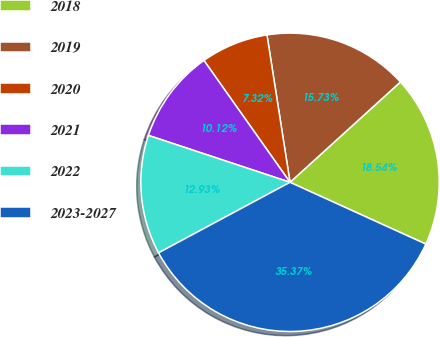Convert chart. <chart><loc_0><loc_0><loc_500><loc_500><pie_chart><fcel>2018<fcel>2019<fcel>2020<fcel>2021<fcel>2022<fcel>2023-2027<nl><fcel>18.54%<fcel>15.73%<fcel>7.32%<fcel>10.12%<fcel>12.93%<fcel>35.37%<nl></chart> 